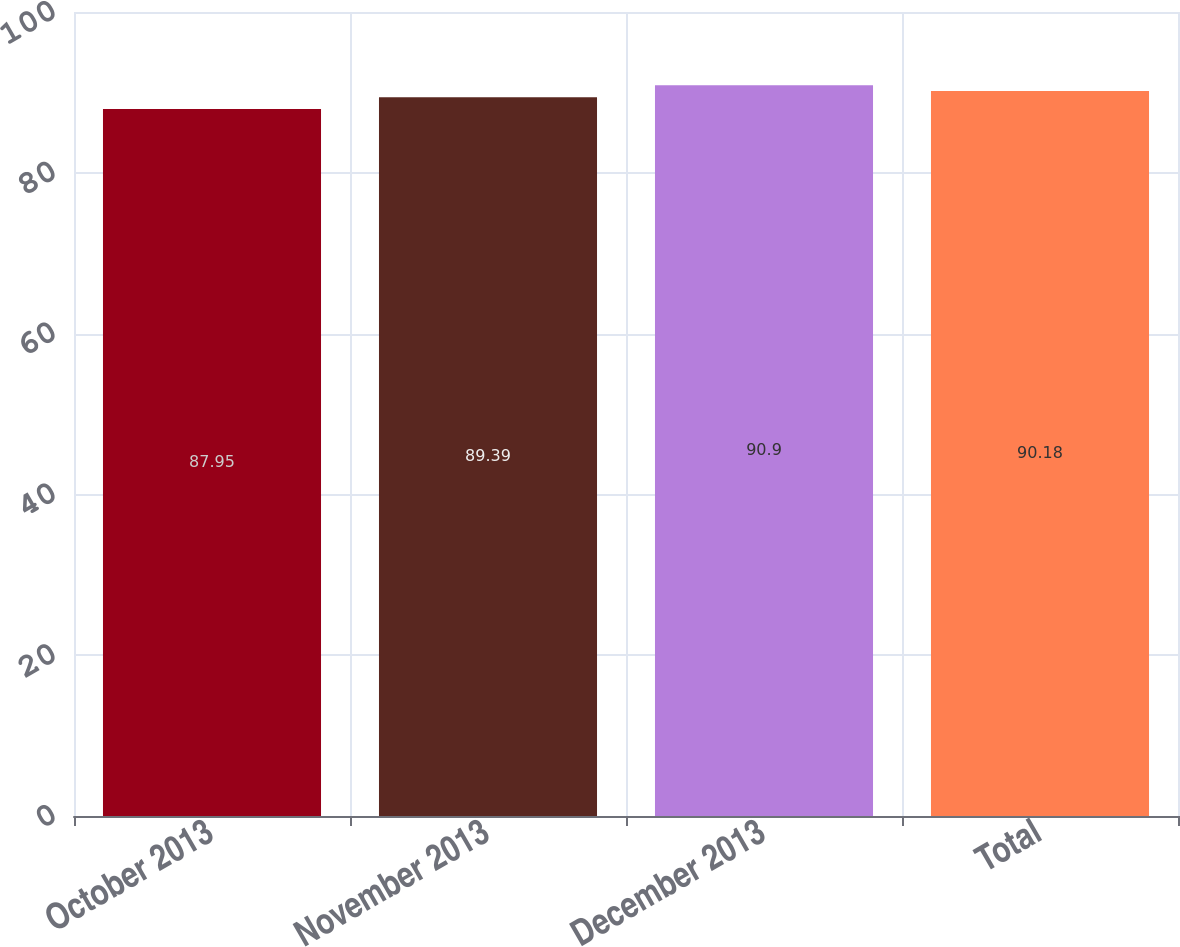<chart> <loc_0><loc_0><loc_500><loc_500><bar_chart><fcel>October 2013<fcel>November 2013<fcel>December 2013<fcel>Total<nl><fcel>87.95<fcel>89.39<fcel>90.9<fcel>90.18<nl></chart> 